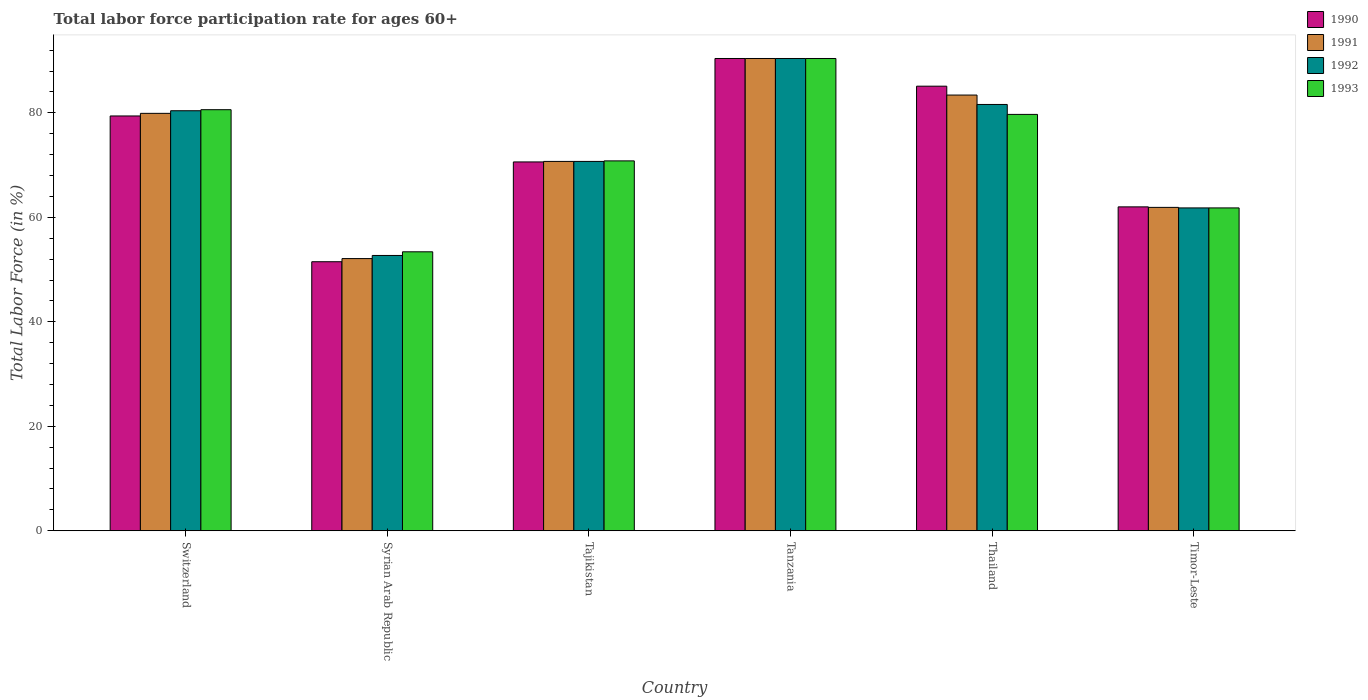How many different coloured bars are there?
Your answer should be very brief. 4. How many groups of bars are there?
Provide a short and direct response. 6. Are the number of bars per tick equal to the number of legend labels?
Provide a succinct answer. Yes. Are the number of bars on each tick of the X-axis equal?
Your answer should be very brief. Yes. How many bars are there on the 1st tick from the left?
Keep it short and to the point. 4. How many bars are there on the 5th tick from the right?
Ensure brevity in your answer.  4. What is the label of the 6th group of bars from the left?
Your answer should be very brief. Timor-Leste. What is the labor force participation rate in 1991 in Tanzania?
Offer a very short reply. 90.4. Across all countries, what is the maximum labor force participation rate in 1992?
Provide a succinct answer. 90.4. Across all countries, what is the minimum labor force participation rate in 1993?
Provide a succinct answer. 53.4. In which country was the labor force participation rate in 1992 maximum?
Give a very brief answer. Tanzania. In which country was the labor force participation rate in 1992 minimum?
Offer a terse response. Syrian Arab Republic. What is the total labor force participation rate in 1993 in the graph?
Offer a terse response. 436.7. What is the difference between the labor force participation rate in 1992 in Syrian Arab Republic and that in Tajikistan?
Offer a very short reply. -18. What is the difference between the labor force participation rate in 1992 in Tanzania and the labor force participation rate in 1990 in Timor-Leste?
Your answer should be compact. 28.4. What is the average labor force participation rate in 1992 per country?
Offer a terse response. 72.93. What is the difference between the labor force participation rate of/in 1992 and labor force participation rate of/in 1990 in Syrian Arab Republic?
Offer a terse response. 1.2. What is the ratio of the labor force participation rate in 1993 in Tanzania to that in Timor-Leste?
Offer a terse response. 1.46. Is the labor force participation rate in 1990 in Switzerland less than that in Tanzania?
Make the answer very short. Yes. What is the difference between the highest and the second highest labor force participation rate in 1992?
Keep it short and to the point. -1.2. What is the difference between the highest and the lowest labor force participation rate in 1992?
Your answer should be very brief. 37.7. In how many countries, is the labor force participation rate in 1991 greater than the average labor force participation rate in 1991 taken over all countries?
Offer a very short reply. 3. Is the sum of the labor force participation rate in 1993 in Tanzania and Thailand greater than the maximum labor force participation rate in 1990 across all countries?
Your answer should be very brief. Yes. What does the 1st bar from the left in Switzerland represents?
Provide a short and direct response. 1990. What does the 4th bar from the right in Thailand represents?
Provide a succinct answer. 1990. Is it the case that in every country, the sum of the labor force participation rate in 1992 and labor force participation rate in 1993 is greater than the labor force participation rate in 1990?
Give a very brief answer. Yes. How many bars are there?
Keep it short and to the point. 24. Are all the bars in the graph horizontal?
Ensure brevity in your answer.  No. How many countries are there in the graph?
Ensure brevity in your answer.  6. Are the values on the major ticks of Y-axis written in scientific E-notation?
Your answer should be very brief. No. Does the graph contain any zero values?
Your answer should be compact. No. Where does the legend appear in the graph?
Your answer should be very brief. Top right. What is the title of the graph?
Offer a very short reply. Total labor force participation rate for ages 60+. What is the Total Labor Force (in %) of 1990 in Switzerland?
Offer a terse response. 79.4. What is the Total Labor Force (in %) of 1991 in Switzerland?
Offer a terse response. 79.9. What is the Total Labor Force (in %) in 1992 in Switzerland?
Give a very brief answer. 80.4. What is the Total Labor Force (in %) in 1993 in Switzerland?
Your answer should be very brief. 80.6. What is the Total Labor Force (in %) in 1990 in Syrian Arab Republic?
Your response must be concise. 51.5. What is the Total Labor Force (in %) in 1991 in Syrian Arab Republic?
Offer a terse response. 52.1. What is the Total Labor Force (in %) of 1992 in Syrian Arab Republic?
Give a very brief answer. 52.7. What is the Total Labor Force (in %) of 1993 in Syrian Arab Republic?
Offer a terse response. 53.4. What is the Total Labor Force (in %) of 1990 in Tajikistan?
Provide a short and direct response. 70.6. What is the Total Labor Force (in %) in 1991 in Tajikistan?
Keep it short and to the point. 70.7. What is the Total Labor Force (in %) in 1992 in Tajikistan?
Provide a short and direct response. 70.7. What is the Total Labor Force (in %) in 1993 in Tajikistan?
Ensure brevity in your answer.  70.8. What is the Total Labor Force (in %) in 1990 in Tanzania?
Your answer should be compact. 90.4. What is the Total Labor Force (in %) in 1991 in Tanzania?
Make the answer very short. 90.4. What is the Total Labor Force (in %) in 1992 in Tanzania?
Your response must be concise. 90.4. What is the Total Labor Force (in %) in 1993 in Tanzania?
Ensure brevity in your answer.  90.4. What is the Total Labor Force (in %) in 1990 in Thailand?
Your answer should be compact. 85.1. What is the Total Labor Force (in %) in 1991 in Thailand?
Provide a succinct answer. 83.4. What is the Total Labor Force (in %) of 1992 in Thailand?
Keep it short and to the point. 81.6. What is the Total Labor Force (in %) in 1993 in Thailand?
Your answer should be compact. 79.7. What is the Total Labor Force (in %) in 1990 in Timor-Leste?
Offer a terse response. 62. What is the Total Labor Force (in %) of 1991 in Timor-Leste?
Your response must be concise. 61.9. What is the Total Labor Force (in %) in 1992 in Timor-Leste?
Ensure brevity in your answer.  61.8. What is the Total Labor Force (in %) in 1993 in Timor-Leste?
Keep it short and to the point. 61.8. Across all countries, what is the maximum Total Labor Force (in %) in 1990?
Keep it short and to the point. 90.4. Across all countries, what is the maximum Total Labor Force (in %) of 1991?
Your answer should be very brief. 90.4. Across all countries, what is the maximum Total Labor Force (in %) of 1992?
Ensure brevity in your answer.  90.4. Across all countries, what is the maximum Total Labor Force (in %) of 1993?
Your answer should be compact. 90.4. Across all countries, what is the minimum Total Labor Force (in %) in 1990?
Offer a very short reply. 51.5. Across all countries, what is the minimum Total Labor Force (in %) of 1991?
Your answer should be compact. 52.1. Across all countries, what is the minimum Total Labor Force (in %) in 1992?
Ensure brevity in your answer.  52.7. Across all countries, what is the minimum Total Labor Force (in %) of 1993?
Keep it short and to the point. 53.4. What is the total Total Labor Force (in %) in 1990 in the graph?
Your answer should be very brief. 439. What is the total Total Labor Force (in %) in 1991 in the graph?
Provide a succinct answer. 438.4. What is the total Total Labor Force (in %) of 1992 in the graph?
Ensure brevity in your answer.  437.6. What is the total Total Labor Force (in %) of 1993 in the graph?
Give a very brief answer. 436.7. What is the difference between the Total Labor Force (in %) of 1990 in Switzerland and that in Syrian Arab Republic?
Your answer should be compact. 27.9. What is the difference between the Total Labor Force (in %) in 1991 in Switzerland and that in Syrian Arab Republic?
Offer a very short reply. 27.8. What is the difference between the Total Labor Force (in %) of 1992 in Switzerland and that in Syrian Arab Republic?
Offer a terse response. 27.7. What is the difference between the Total Labor Force (in %) in 1993 in Switzerland and that in Syrian Arab Republic?
Offer a very short reply. 27.2. What is the difference between the Total Labor Force (in %) in 1991 in Switzerland and that in Tajikistan?
Offer a terse response. 9.2. What is the difference between the Total Labor Force (in %) in 1992 in Switzerland and that in Tanzania?
Provide a succinct answer. -10. What is the difference between the Total Labor Force (in %) in 1990 in Switzerland and that in Thailand?
Your answer should be compact. -5.7. What is the difference between the Total Labor Force (in %) in 1991 in Switzerland and that in Timor-Leste?
Your answer should be compact. 18. What is the difference between the Total Labor Force (in %) in 1993 in Switzerland and that in Timor-Leste?
Provide a succinct answer. 18.8. What is the difference between the Total Labor Force (in %) of 1990 in Syrian Arab Republic and that in Tajikistan?
Give a very brief answer. -19.1. What is the difference between the Total Labor Force (in %) of 1991 in Syrian Arab Republic and that in Tajikistan?
Ensure brevity in your answer.  -18.6. What is the difference between the Total Labor Force (in %) of 1993 in Syrian Arab Republic and that in Tajikistan?
Make the answer very short. -17.4. What is the difference between the Total Labor Force (in %) in 1990 in Syrian Arab Republic and that in Tanzania?
Your answer should be compact. -38.9. What is the difference between the Total Labor Force (in %) of 1991 in Syrian Arab Republic and that in Tanzania?
Offer a terse response. -38.3. What is the difference between the Total Labor Force (in %) of 1992 in Syrian Arab Republic and that in Tanzania?
Make the answer very short. -37.7. What is the difference between the Total Labor Force (in %) in 1993 in Syrian Arab Republic and that in Tanzania?
Your answer should be very brief. -37. What is the difference between the Total Labor Force (in %) in 1990 in Syrian Arab Republic and that in Thailand?
Keep it short and to the point. -33.6. What is the difference between the Total Labor Force (in %) of 1991 in Syrian Arab Republic and that in Thailand?
Offer a very short reply. -31.3. What is the difference between the Total Labor Force (in %) of 1992 in Syrian Arab Republic and that in Thailand?
Offer a terse response. -28.9. What is the difference between the Total Labor Force (in %) of 1993 in Syrian Arab Republic and that in Thailand?
Offer a terse response. -26.3. What is the difference between the Total Labor Force (in %) of 1990 in Syrian Arab Republic and that in Timor-Leste?
Give a very brief answer. -10.5. What is the difference between the Total Labor Force (in %) of 1992 in Syrian Arab Republic and that in Timor-Leste?
Make the answer very short. -9.1. What is the difference between the Total Labor Force (in %) of 1993 in Syrian Arab Republic and that in Timor-Leste?
Ensure brevity in your answer.  -8.4. What is the difference between the Total Labor Force (in %) of 1990 in Tajikistan and that in Tanzania?
Offer a terse response. -19.8. What is the difference between the Total Labor Force (in %) in 1991 in Tajikistan and that in Tanzania?
Offer a terse response. -19.7. What is the difference between the Total Labor Force (in %) in 1992 in Tajikistan and that in Tanzania?
Ensure brevity in your answer.  -19.7. What is the difference between the Total Labor Force (in %) of 1993 in Tajikistan and that in Tanzania?
Your answer should be very brief. -19.6. What is the difference between the Total Labor Force (in %) of 1990 in Tajikistan and that in Thailand?
Ensure brevity in your answer.  -14.5. What is the difference between the Total Labor Force (in %) of 1992 in Tajikistan and that in Thailand?
Your answer should be very brief. -10.9. What is the difference between the Total Labor Force (in %) of 1991 in Tanzania and that in Thailand?
Give a very brief answer. 7. What is the difference between the Total Labor Force (in %) in 1990 in Tanzania and that in Timor-Leste?
Provide a short and direct response. 28.4. What is the difference between the Total Labor Force (in %) in 1991 in Tanzania and that in Timor-Leste?
Make the answer very short. 28.5. What is the difference between the Total Labor Force (in %) in 1992 in Tanzania and that in Timor-Leste?
Provide a succinct answer. 28.6. What is the difference between the Total Labor Force (in %) of 1993 in Tanzania and that in Timor-Leste?
Your response must be concise. 28.6. What is the difference between the Total Labor Force (in %) in 1990 in Thailand and that in Timor-Leste?
Your answer should be very brief. 23.1. What is the difference between the Total Labor Force (in %) of 1992 in Thailand and that in Timor-Leste?
Your answer should be compact. 19.8. What is the difference between the Total Labor Force (in %) in 1990 in Switzerland and the Total Labor Force (in %) in 1991 in Syrian Arab Republic?
Make the answer very short. 27.3. What is the difference between the Total Labor Force (in %) in 1990 in Switzerland and the Total Labor Force (in %) in 1992 in Syrian Arab Republic?
Your response must be concise. 26.7. What is the difference between the Total Labor Force (in %) of 1990 in Switzerland and the Total Labor Force (in %) of 1993 in Syrian Arab Republic?
Provide a short and direct response. 26. What is the difference between the Total Labor Force (in %) in 1991 in Switzerland and the Total Labor Force (in %) in 1992 in Syrian Arab Republic?
Your response must be concise. 27.2. What is the difference between the Total Labor Force (in %) in 1991 in Switzerland and the Total Labor Force (in %) in 1993 in Syrian Arab Republic?
Your answer should be compact. 26.5. What is the difference between the Total Labor Force (in %) of 1990 in Switzerland and the Total Labor Force (in %) of 1992 in Tajikistan?
Keep it short and to the point. 8.7. What is the difference between the Total Labor Force (in %) of 1990 in Switzerland and the Total Labor Force (in %) of 1991 in Tanzania?
Provide a short and direct response. -11. What is the difference between the Total Labor Force (in %) of 1990 in Switzerland and the Total Labor Force (in %) of 1992 in Tanzania?
Offer a very short reply. -11. What is the difference between the Total Labor Force (in %) in 1990 in Switzerland and the Total Labor Force (in %) in 1993 in Tanzania?
Provide a short and direct response. -11. What is the difference between the Total Labor Force (in %) of 1991 in Switzerland and the Total Labor Force (in %) of 1992 in Tanzania?
Give a very brief answer. -10.5. What is the difference between the Total Labor Force (in %) in 1991 in Switzerland and the Total Labor Force (in %) in 1993 in Thailand?
Your answer should be very brief. 0.2. What is the difference between the Total Labor Force (in %) in 1990 in Switzerland and the Total Labor Force (in %) in 1991 in Timor-Leste?
Your answer should be very brief. 17.5. What is the difference between the Total Labor Force (in %) in 1990 in Switzerland and the Total Labor Force (in %) in 1993 in Timor-Leste?
Offer a very short reply. 17.6. What is the difference between the Total Labor Force (in %) in 1992 in Switzerland and the Total Labor Force (in %) in 1993 in Timor-Leste?
Provide a short and direct response. 18.6. What is the difference between the Total Labor Force (in %) of 1990 in Syrian Arab Republic and the Total Labor Force (in %) of 1991 in Tajikistan?
Ensure brevity in your answer.  -19.2. What is the difference between the Total Labor Force (in %) of 1990 in Syrian Arab Republic and the Total Labor Force (in %) of 1992 in Tajikistan?
Ensure brevity in your answer.  -19.2. What is the difference between the Total Labor Force (in %) of 1990 in Syrian Arab Republic and the Total Labor Force (in %) of 1993 in Tajikistan?
Offer a very short reply. -19.3. What is the difference between the Total Labor Force (in %) of 1991 in Syrian Arab Republic and the Total Labor Force (in %) of 1992 in Tajikistan?
Give a very brief answer. -18.6. What is the difference between the Total Labor Force (in %) in 1991 in Syrian Arab Republic and the Total Labor Force (in %) in 1993 in Tajikistan?
Your response must be concise. -18.7. What is the difference between the Total Labor Force (in %) of 1992 in Syrian Arab Republic and the Total Labor Force (in %) of 1993 in Tajikistan?
Offer a very short reply. -18.1. What is the difference between the Total Labor Force (in %) in 1990 in Syrian Arab Republic and the Total Labor Force (in %) in 1991 in Tanzania?
Make the answer very short. -38.9. What is the difference between the Total Labor Force (in %) of 1990 in Syrian Arab Republic and the Total Labor Force (in %) of 1992 in Tanzania?
Keep it short and to the point. -38.9. What is the difference between the Total Labor Force (in %) of 1990 in Syrian Arab Republic and the Total Labor Force (in %) of 1993 in Tanzania?
Provide a short and direct response. -38.9. What is the difference between the Total Labor Force (in %) in 1991 in Syrian Arab Republic and the Total Labor Force (in %) in 1992 in Tanzania?
Your response must be concise. -38.3. What is the difference between the Total Labor Force (in %) in 1991 in Syrian Arab Republic and the Total Labor Force (in %) in 1993 in Tanzania?
Your answer should be very brief. -38.3. What is the difference between the Total Labor Force (in %) in 1992 in Syrian Arab Republic and the Total Labor Force (in %) in 1993 in Tanzania?
Give a very brief answer. -37.7. What is the difference between the Total Labor Force (in %) in 1990 in Syrian Arab Republic and the Total Labor Force (in %) in 1991 in Thailand?
Your answer should be very brief. -31.9. What is the difference between the Total Labor Force (in %) of 1990 in Syrian Arab Republic and the Total Labor Force (in %) of 1992 in Thailand?
Provide a short and direct response. -30.1. What is the difference between the Total Labor Force (in %) in 1990 in Syrian Arab Republic and the Total Labor Force (in %) in 1993 in Thailand?
Offer a terse response. -28.2. What is the difference between the Total Labor Force (in %) in 1991 in Syrian Arab Republic and the Total Labor Force (in %) in 1992 in Thailand?
Your answer should be compact. -29.5. What is the difference between the Total Labor Force (in %) in 1991 in Syrian Arab Republic and the Total Labor Force (in %) in 1993 in Thailand?
Make the answer very short. -27.6. What is the difference between the Total Labor Force (in %) of 1992 in Syrian Arab Republic and the Total Labor Force (in %) of 1993 in Thailand?
Provide a short and direct response. -27. What is the difference between the Total Labor Force (in %) of 1990 in Syrian Arab Republic and the Total Labor Force (in %) of 1991 in Timor-Leste?
Provide a short and direct response. -10.4. What is the difference between the Total Labor Force (in %) in 1990 in Syrian Arab Republic and the Total Labor Force (in %) in 1992 in Timor-Leste?
Make the answer very short. -10.3. What is the difference between the Total Labor Force (in %) in 1990 in Syrian Arab Republic and the Total Labor Force (in %) in 1993 in Timor-Leste?
Your answer should be very brief. -10.3. What is the difference between the Total Labor Force (in %) in 1991 in Syrian Arab Republic and the Total Labor Force (in %) in 1993 in Timor-Leste?
Provide a succinct answer. -9.7. What is the difference between the Total Labor Force (in %) in 1992 in Syrian Arab Republic and the Total Labor Force (in %) in 1993 in Timor-Leste?
Keep it short and to the point. -9.1. What is the difference between the Total Labor Force (in %) in 1990 in Tajikistan and the Total Labor Force (in %) in 1991 in Tanzania?
Ensure brevity in your answer.  -19.8. What is the difference between the Total Labor Force (in %) of 1990 in Tajikistan and the Total Labor Force (in %) of 1992 in Tanzania?
Make the answer very short. -19.8. What is the difference between the Total Labor Force (in %) of 1990 in Tajikistan and the Total Labor Force (in %) of 1993 in Tanzania?
Provide a short and direct response. -19.8. What is the difference between the Total Labor Force (in %) of 1991 in Tajikistan and the Total Labor Force (in %) of 1992 in Tanzania?
Offer a very short reply. -19.7. What is the difference between the Total Labor Force (in %) in 1991 in Tajikistan and the Total Labor Force (in %) in 1993 in Tanzania?
Ensure brevity in your answer.  -19.7. What is the difference between the Total Labor Force (in %) of 1992 in Tajikistan and the Total Labor Force (in %) of 1993 in Tanzania?
Give a very brief answer. -19.7. What is the difference between the Total Labor Force (in %) in 1990 in Tajikistan and the Total Labor Force (in %) in 1993 in Thailand?
Your answer should be very brief. -9.1. What is the difference between the Total Labor Force (in %) in 1991 in Tajikistan and the Total Labor Force (in %) in 1992 in Thailand?
Your response must be concise. -10.9. What is the difference between the Total Labor Force (in %) of 1990 in Tajikistan and the Total Labor Force (in %) of 1991 in Timor-Leste?
Make the answer very short. 8.7. What is the difference between the Total Labor Force (in %) of 1990 in Tajikistan and the Total Labor Force (in %) of 1993 in Timor-Leste?
Your response must be concise. 8.8. What is the difference between the Total Labor Force (in %) in 1991 in Tajikistan and the Total Labor Force (in %) in 1993 in Timor-Leste?
Make the answer very short. 8.9. What is the difference between the Total Labor Force (in %) of 1992 in Tajikistan and the Total Labor Force (in %) of 1993 in Timor-Leste?
Your response must be concise. 8.9. What is the difference between the Total Labor Force (in %) in 1990 in Tanzania and the Total Labor Force (in %) in 1991 in Thailand?
Keep it short and to the point. 7. What is the difference between the Total Labor Force (in %) in 1990 in Tanzania and the Total Labor Force (in %) in 1992 in Thailand?
Make the answer very short. 8.8. What is the difference between the Total Labor Force (in %) in 1990 in Tanzania and the Total Labor Force (in %) in 1993 in Thailand?
Ensure brevity in your answer.  10.7. What is the difference between the Total Labor Force (in %) in 1991 in Tanzania and the Total Labor Force (in %) in 1992 in Thailand?
Provide a short and direct response. 8.8. What is the difference between the Total Labor Force (in %) in 1991 in Tanzania and the Total Labor Force (in %) in 1993 in Thailand?
Provide a short and direct response. 10.7. What is the difference between the Total Labor Force (in %) of 1992 in Tanzania and the Total Labor Force (in %) of 1993 in Thailand?
Ensure brevity in your answer.  10.7. What is the difference between the Total Labor Force (in %) in 1990 in Tanzania and the Total Labor Force (in %) in 1991 in Timor-Leste?
Keep it short and to the point. 28.5. What is the difference between the Total Labor Force (in %) in 1990 in Tanzania and the Total Labor Force (in %) in 1992 in Timor-Leste?
Offer a terse response. 28.6. What is the difference between the Total Labor Force (in %) in 1990 in Tanzania and the Total Labor Force (in %) in 1993 in Timor-Leste?
Provide a succinct answer. 28.6. What is the difference between the Total Labor Force (in %) in 1991 in Tanzania and the Total Labor Force (in %) in 1992 in Timor-Leste?
Offer a very short reply. 28.6. What is the difference between the Total Labor Force (in %) in 1991 in Tanzania and the Total Labor Force (in %) in 1993 in Timor-Leste?
Keep it short and to the point. 28.6. What is the difference between the Total Labor Force (in %) of 1992 in Tanzania and the Total Labor Force (in %) of 1993 in Timor-Leste?
Offer a terse response. 28.6. What is the difference between the Total Labor Force (in %) in 1990 in Thailand and the Total Labor Force (in %) in 1991 in Timor-Leste?
Offer a very short reply. 23.2. What is the difference between the Total Labor Force (in %) of 1990 in Thailand and the Total Labor Force (in %) of 1992 in Timor-Leste?
Make the answer very short. 23.3. What is the difference between the Total Labor Force (in %) in 1990 in Thailand and the Total Labor Force (in %) in 1993 in Timor-Leste?
Provide a succinct answer. 23.3. What is the difference between the Total Labor Force (in %) of 1991 in Thailand and the Total Labor Force (in %) of 1992 in Timor-Leste?
Ensure brevity in your answer.  21.6. What is the difference between the Total Labor Force (in %) in 1991 in Thailand and the Total Labor Force (in %) in 1993 in Timor-Leste?
Offer a very short reply. 21.6. What is the difference between the Total Labor Force (in %) of 1992 in Thailand and the Total Labor Force (in %) of 1993 in Timor-Leste?
Provide a short and direct response. 19.8. What is the average Total Labor Force (in %) in 1990 per country?
Offer a very short reply. 73.17. What is the average Total Labor Force (in %) of 1991 per country?
Provide a succinct answer. 73.07. What is the average Total Labor Force (in %) of 1992 per country?
Offer a terse response. 72.93. What is the average Total Labor Force (in %) of 1993 per country?
Provide a short and direct response. 72.78. What is the difference between the Total Labor Force (in %) in 1990 and Total Labor Force (in %) in 1993 in Switzerland?
Keep it short and to the point. -1.2. What is the difference between the Total Labor Force (in %) of 1991 and Total Labor Force (in %) of 1992 in Switzerland?
Provide a short and direct response. -0.5. What is the difference between the Total Labor Force (in %) of 1992 and Total Labor Force (in %) of 1993 in Switzerland?
Offer a very short reply. -0.2. What is the difference between the Total Labor Force (in %) of 1990 and Total Labor Force (in %) of 1991 in Syrian Arab Republic?
Offer a terse response. -0.6. What is the difference between the Total Labor Force (in %) in 1990 and Total Labor Force (in %) in 1992 in Syrian Arab Republic?
Your answer should be compact. -1.2. What is the difference between the Total Labor Force (in %) of 1990 and Total Labor Force (in %) of 1993 in Syrian Arab Republic?
Your answer should be very brief. -1.9. What is the difference between the Total Labor Force (in %) of 1991 and Total Labor Force (in %) of 1993 in Syrian Arab Republic?
Provide a short and direct response. -1.3. What is the difference between the Total Labor Force (in %) of 1990 and Total Labor Force (in %) of 1992 in Tajikistan?
Offer a very short reply. -0.1. What is the difference between the Total Labor Force (in %) of 1990 and Total Labor Force (in %) of 1993 in Tajikistan?
Offer a terse response. -0.2. What is the difference between the Total Labor Force (in %) in 1991 and Total Labor Force (in %) in 1992 in Tajikistan?
Give a very brief answer. 0. What is the difference between the Total Labor Force (in %) in 1991 and Total Labor Force (in %) in 1993 in Tajikistan?
Provide a short and direct response. -0.1. What is the difference between the Total Labor Force (in %) of 1992 and Total Labor Force (in %) of 1993 in Tajikistan?
Offer a very short reply. -0.1. What is the difference between the Total Labor Force (in %) of 1990 and Total Labor Force (in %) of 1991 in Tanzania?
Your answer should be very brief. 0. What is the difference between the Total Labor Force (in %) in 1991 and Total Labor Force (in %) in 1992 in Tanzania?
Offer a very short reply. 0. What is the difference between the Total Labor Force (in %) in 1991 and Total Labor Force (in %) in 1993 in Tanzania?
Keep it short and to the point. 0. What is the difference between the Total Labor Force (in %) in 1990 and Total Labor Force (in %) in 1991 in Thailand?
Ensure brevity in your answer.  1.7. What is the difference between the Total Labor Force (in %) in 1991 and Total Labor Force (in %) in 1993 in Thailand?
Offer a terse response. 3.7. What is the difference between the Total Labor Force (in %) of 1992 and Total Labor Force (in %) of 1993 in Thailand?
Make the answer very short. 1.9. What is the difference between the Total Labor Force (in %) of 1990 and Total Labor Force (in %) of 1991 in Timor-Leste?
Keep it short and to the point. 0.1. What is the difference between the Total Labor Force (in %) of 1990 and Total Labor Force (in %) of 1992 in Timor-Leste?
Provide a succinct answer. 0.2. What is the difference between the Total Labor Force (in %) of 1991 and Total Labor Force (in %) of 1993 in Timor-Leste?
Keep it short and to the point. 0.1. What is the ratio of the Total Labor Force (in %) of 1990 in Switzerland to that in Syrian Arab Republic?
Make the answer very short. 1.54. What is the ratio of the Total Labor Force (in %) in 1991 in Switzerland to that in Syrian Arab Republic?
Provide a succinct answer. 1.53. What is the ratio of the Total Labor Force (in %) of 1992 in Switzerland to that in Syrian Arab Republic?
Provide a short and direct response. 1.53. What is the ratio of the Total Labor Force (in %) of 1993 in Switzerland to that in Syrian Arab Republic?
Your answer should be very brief. 1.51. What is the ratio of the Total Labor Force (in %) of 1990 in Switzerland to that in Tajikistan?
Provide a short and direct response. 1.12. What is the ratio of the Total Labor Force (in %) of 1991 in Switzerland to that in Tajikistan?
Ensure brevity in your answer.  1.13. What is the ratio of the Total Labor Force (in %) in 1992 in Switzerland to that in Tajikistan?
Offer a terse response. 1.14. What is the ratio of the Total Labor Force (in %) in 1993 in Switzerland to that in Tajikistan?
Make the answer very short. 1.14. What is the ratio of the Total Labor Force (in %) of 1990 in Switzerland to that in Tanzania?
Offer a terse response. 0.88. What is the ratio of the Total Labor Force (in %) of 1991 in Switzerland to that in Tanzania?
Offer a very short reply. 0.88. What is the ratio of the Total Labor Force (in %) of 1992 in Switzerland to that in Tanzania?
Make the answer very short. 0.89. What is the ratio of the Total Labor Force (in %) of 1993 in Switzerland to that in Tanzania?
Your answer should be very brief. 0.89. What is the ratio of the Total Labor Force (in %) in 1990 in Switzerland to that in Thailand?
Offer a very short reply. 0.93. What is the ratio of the Total Labor Force (in %) in 1991 in Switzerland to that in Thailand?
Your response must be concise. 0.96. What is the ratio of the Total Labor Force (in %) in 1993 in Switzerland to that in Thailand?
Offer a terse response. 1.01. What is the ratio of the Total Labor Force (in %) of 1990 in Switzerland to that in Timor-Leste?
Your answer should be compact. 1.28. What is the ratio of the Total Labor Force (in %) of 1991 in Switzerland to that in Timor-Leste?
Ensure brevity in your answer.  1.29. What is the ratio of the Total Labor Force (in %) of 1992 in Switzerland to that in Timor-Leste?
Give a very brief answer. 1.3. What is the ratio of the Total Labor Force (in %) in 1993 in Switzerland to that in Timor-Leste?
Give a very brief answer. 1.3. What is the ratio of the Total Labor Force (in %) in 1990 in Syrian Arab Republic to that in Tajikistan?
Make the answer very short. 0.73. What is the ratio of the Total Labor Force (in %) in 1991 in Syrian Arab Republic to that in Tajikistan?
Offer a very short reply. 0.74. What is the ratio of the Total Labor Force (in %) in 1992 in Syrian Arab Republic to that in Tajikistan?
Your answer should be compact. 0.75. What is the ratio of the Total Labor Force (in %) in 1993 in Syrian Arab Republic to that in Tajikistan?
Keep it short and to the point. 0.75. What is the ratio of the Total Labor Force (in %) of 1990 in Syrian Arab Republic to that in Tanzania?
Provide a succinct answer. 0.57. What is the ratio of the Total Labor Force (in %) in 1991 in Syrian Arab Republic to that in Tanzania?
Provide a short and direct response. 0.58. What is the ratio of the Total Labor Force (in %) of 1992 in Syrian Arab Republic to that in Tanzania?
Your answer should be very brief. 0.58. What is the ratio of the Total Labor Force (in %) of 1993 in Syrian Arab Republic to that in Tanzania?
Your answer should be compact. 0.59. What is the ratio of the Total Labor Force (in %) of 1990 in Syrian Arab Republic to that in Thailand?
Keep it short and to the point. 0.61. What is the ratio of the Total Labor Force (in %) in 1991 in Syrian Arab Republic to that in Thailand?
Your answer should be very brief. 0.62. What is the ratio of the Total Labor Force (in %) of 1992 in Syrian Arab Republic to that in Thailand?
Your answer should be compact. 0.65. What is the ratio of the Total Labor Force (in %) in 1993 in Syrian Arab Republic to that in Thailand?
Your answer should be compact. 0.67. What is the ratio of the Total Labor Force (in %) in 1990 in Syrian Arab Republic to that in Timor-Leste?
Make the answer very short. 0.83. What is the ratio of the Total Labor Force (in %) in 1991 in Syrian Arab Republic to that in Timor-Leste?
Provide a short and direct response. 0.84. What is the ratio of the Total Labor Force (in %) of 1992 in Syrian Arab Republic to that in Timor-Leste?
Your answer should be very brief. 0.85. What is the ratio of the Total Labor Force (in %) of 1993 in Syrian Arab Republic to that in Timor-Leste?
Your answer should be very brief. 0.86. What is the ratio of the Total Labor Force (in %) in 1990 in Tajikistan to that in Tanzania?
Give a very brief answer. 0.78. What is the ratio of the Total Labor Force (in %) of 1991 in Tajikistan to that in Tanzania?
Provide a short and direct response. 0.78. What is the ratio of the Total Labor Force (in %) of 1992 in Tajikistan to that in Tanzania?
Provide a succinct answer. 0.78. What is the ratio of the Total Labor Force (in %) of 1993 in Tajikistan to that in Tanzania?
Provide a succinct answer. 0.78. What is the ratio of the Total Labor Force (in %) in 1990 in Tajikistan to that in Thailand?
Make the answer very short. 0.83. What is the ratio of the Total Labor Force (in %) of 1991 in Tajikistan to that in Thailand?
Offer a very short reply. 0.85. What is the ratio of the Total Labor Force (in %) in 1992 in Tajikistan to that in Thailand?
Give a very brief answer. 0.87. What is the ratio of the Total Labor Force (in %) of 1993 in Tajikistan to that in Thailand?
Offer a terse response. 0.89. What is the ratio of the Total Labor Force (in %) of 1990 in Tajikistan to that in Timor-Leste?
Keep it short and to the point. 1.14. What is the ratio of the Total Labor Force (in %) of 1991 in Tajikistan to that in Timor-Leste?
Your response must be concise. 1.14. What is the ratio of the Total Labor Force (in %) in 1992 in Tajikistan to that in Timor-Leste?
Your answer should be compact. 1.14. What is the ratio of the Total Labor Force (in %) of 1993 in Tajikistan to that in Timor-Leste?
Offer a very short reply. 1.15. What is the ratio of the Total Labor Force (in %) in 1990 in Tanzania to that in Thailand?
Give a very brief answer. 1.06. What is the ratio of the Total Labor Force (in %) in 1991 in Tanzania to that in Thailand?
Keep it short and to the point. 1.08. What is the ratio of the Total Labor Force (in %) of 1992 in Tanzania to that in Thailand?
Your answer should be compact. 1.11. What is the ratio of the Total Labor Force (in %) of 1993 in Tanzania to that in Thailand?
Your response must be concise. 1.13. What is the ratio of the Total Labor Force (in %) of 1990 in Tanzania to that in Timor-Leste?
Give a very brief answer. 1.46. What is the ratio of the Total Labor Force (in %) of 1991 in Tanzania to that in Timor-Leste?
Offer a terse response. 1.46. What is the ratio of the Total Labor Force (in %) in 1992 in Tanzania to that in Timor-Leste?
Offer a terse response. 1.46. What is the ratio of the Total Labor Force (in %) of 1993 in Tanzania to that in Timor-Leste?
Make the answer very short. 1.46. What is the ratio of the Total Labor Force (in %) in 1990 in Thailand to that in Timor-Leste?
Give a very brief answer. 1.37. What is the ratio of the Total Labor Force (in %) in 1991 in Thailand to that in Timor-Leste?
Make the answer very short. 1.35. What is the ratio of the Total Labor Force (in %) in 1992 in Thailand to that in Timor-Leste?
Keep it short and to the point. 1.32. What is the ratio of the Total Labor Force (in %) in 1993 in Thailand to that in Timor-Leste?
Give a very brief answer. 1.29. What is the difference between the highest and the second highest Total Labor Force (in %) of 1990?
Make the answer very short. 5.3. What is the difference between the highest and the second highest Total Labor Force (in %) in 1992?
Your answer should be compact. 8.8. What is the difference between the highest and the lowest Total Labor Force (in %) in 1990?
Make the answer very short. 38.9. What is the difference between the highest and the lowest Total Labor Force (in %) in 1991?
Offer a very short reply. 38.3. What is the difference between the highest and the lowest Total Labor Force (in %) in 1992?
Make the answer very short. 37.7. 